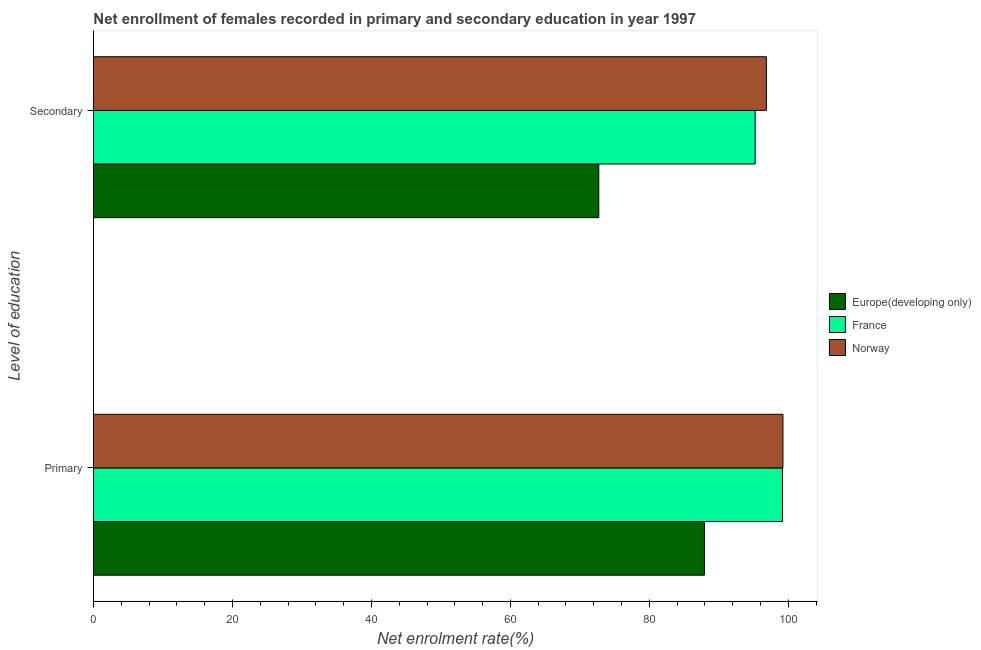Are the number of bars per tick equal to the number of legend labels?
Offer a terse response. Yes. Are the number of bars on each tick of the Y-axis equal?
Keep it short and to the point. Yes. How many bars are there on the 2nd tick from the top?
Your answer should be very brief. 3. How many bars are there on the 1st tick from the bottom?
Make the answer very short. 3. What is the label of the 1st group of bars from the top?
Your answer should be compact. Secondary. What is the enrollment rate in primary education in Norway?
Provide a succinct answer. 99.23. Across all countries, what is the maximum enrollment rate in secondary education?
Provide a succinct answer. 96.84. Across all countries, what is the minimum enrollment rate in primary education?
Provide a short and direct response. 87.93. In which country was the enrollment rate in primary education minimum?
Your answer should be compact. Europe(developing only). What is the total enrollment rate in primary education in the graph?
Offer a very short reply. 286.31. What is the difference between the enrollment rate in primary education in Europe(developing only) and that in France?
Give a very brief answer. -11.23. What is the difference between the enrollment rate in primary education in France and the enrollment rate in secondary education in Europe(developing only)?
Your answer should be very brief. 26.43. What is the average enrollment rate in secondary education per country?
Give a very brief answer. 88.26. What is the difference between the enrollment rate in secondary education and enrollment rate in primary education in Europe(developing only)?
Your answer should be compact. -15.21. In how many countries, is the enrollment rate in secondary education greater than 52 %?
Your response must be concise. 3. What is the ratio of the enrollment rate in secondary education in Norway to that in France?
Provide a succinct answer. 1.02. Is the enrollment rate in primary education in Norway less than that in Europe(developing only)?
Provide a short and direct response. No. In how many countries, is the enrollment rate in primary education greater than the average enrollment rate in primary education taken over all countries?
Your response must be concise. 2. What does the 3rd bar from the bottom in Secondary represents?
Keep it short and to the point. Norway. Are the values on the major ticks of X-axis written in scientific E-notation?
Your response must be concise. No. Does the graph contain any zero values?
Make the answer very short. No. Does the graph contain grids?
Give a very brief answer. No. How many legend labels are there?
Provide a succinct answer. 3. How are the legend labels stacked?
Your answer should be compact. Vertical. What is the title of the graph?
Provide a short and direct response. Net enrollment of females recorded in primary and secondary education in year 1997. What is the label or title of the X-axis?
Give a very brief answer. Net enrolment rate(%). What is the label or title of the Y-axis?
Provide a succinct answer. Level of education. What is the Net enrolment rate(%) of Europe(developing only) in Primary?
Provide a succinct answer. 87.93. What is the Net enrolment rate(%) of France in Primary?
Make the answer very short. 99.16. What is the Net enrolment rate(%) of Norway in Primary?
Provide a short and direct response. 99.23. What is the Net enrolment rate(%) of Europe(developing only) in Secondary?
Offer a terse response. 72.72. What is the Net enrolment rate(%) of France in Secondary?
Your answer should be very brief. 95.23. What is the Net enrolment rate(%) of Norway in Secondary?
Provide a short and direct response. 96.84. Across all Level of education, what is the maximum Net enrolment rate(%) in Europe(developing only)?
Your answer should be very brief. 87.93. Across all Level of education, what is the maximum Net enrolment rate(%) of France?
Ensure brevity in your answer.  99.16. Across all Level of education, what is the maximum Net enrolment rate(%) in Norway?
Provide a short and direct response. 99.23. Across all Level of education, what is the minimum Net enrolment rate(%) of Europe(developing only)?
Offer a terse response. 72.72. Across all Level of education, what is the minimum Net enrolment rate(%) in France?
Ensure brevity in your answer.  95.23. Across all Level of education, what is the minimum Net enrolment rate(%) in Norway?
Offer a very short reply. 96.84. What is the total Net enrolment rate(%) of Europe(developing only) in the graph?
Offer a very short reply. 160.65. What is the total Net enrolment rate(%) in France in the graph?
Provide a succinct answer. 194.38. What is the total Net enrolment rate(%) in Norway in the graph?
Give a very brief answer. 196.07. What is the difference between the Net enrolment rate(%) in Europe(developing only) in Primary and that in Secondary?
Your answer should be very brief. 15.21. What is the difference between the Net enrolment rate(%) of France in Primary and that in Secondary?
Your response must be concise. 3.93. What is the difference between the Net enrolment rate(%) in Norway in Primary and that in Secondary?
Your response must be concise. 2.38. What is the difference between the Net enrolment rate(%) of Europe(developing only) in Primary and the Net enrolment rate(%) of France in Secondary?
Keep it short and to the point. -7.3. What is the difference between the Net enrolment rate(%) of Europe(developing only) in Primary and the Net enrolment rate(%) of Norway in Secondary?
Your answer should be compact. -8.91. What is the difference between the Net enrolment rate(%) of France in Primary and the Net enrolment rate(%) of Norway in Secondary?
Your answer should be very brief. 2.31. What is the average Net enrolment rate(%) in Europe(developing only) per Level of education?
Your answer should be compact. 80.32. What is the average Net enrolment rate(%) in France per Level of education?
Make the answer very short. 97.19. What is the average Net enrolment rate(%) in Norway per Level of education?
Your answer should be compact. 98.03. What is the difference between the Net enrolment rate(%) in Europe(developing only) and Net enrolment rate(%) in France in Primary?
Your response must be concise. -11.23. What is the difference between the Net enrolment rate(%) in Europe(developing only) and Net enrolment rate(%) in Norway in Primary?
Ensure brevity in your answer.  -11.3. What is the difference between the Net enrolment rate(%) in France and Net enrolment rate(%) in Norway in Primary?
Make the answer very short. -0.07. What is the difference between the Net enrolment rate(%) in Europe(developing only) and Net enrolment rate(%) in France in Secondary?
Make the answer very short. -22.51. What is the difference between the Net enrolment rate(%) in Europe(developing only) and Net enrolment rate(%) in Norway in Secondary?
Ensure brevity in your answer.  -24.12. What is the difference between the Net enrolment rate(%) in France and Net enrolment rate(%) in Norway in Secondary?
Keep it short and to the point. -1.61. What is the ratio of the Net enrolment rate(%) of Europe(developing only) in Primary to that in Secondary?
Ensure brevity in your answer.  1.21. What is the ratio of the Net enrolment rate(%) in France in Primary to that in Secondary?
Provide a succinct answer. 1.04. What is the ratio of the Net enrolment rate(%) in Norway in Primary to that in Secondary?
Ensure brevity in your answer.  1.02. What is the difference between the highest and the second highest Net enrolment rate(%) in Europe(developing only)?
Your response must be concise. 15.21. What is the difference between the highest and the second highest Net enrolment rate(%) in France?
Your answer should be very brief. 3.93. What is the difference between the highest and the second highest Net enrolment rate(%) of Norway?
Make the answer very short. 2.38. What is the difference between the highest and the lowest Net enrolment rate(%) of Europe(developing only)?
Give a very brief answer. 15.21. What is the difference between the highest and the lowest Net enrolment rate(%) of France?
Make the answer very short. 3.93. What is the difference between the highest and the lowest Net enrolment rate(%) of Norway?
Make the answer very short. 2.38. 